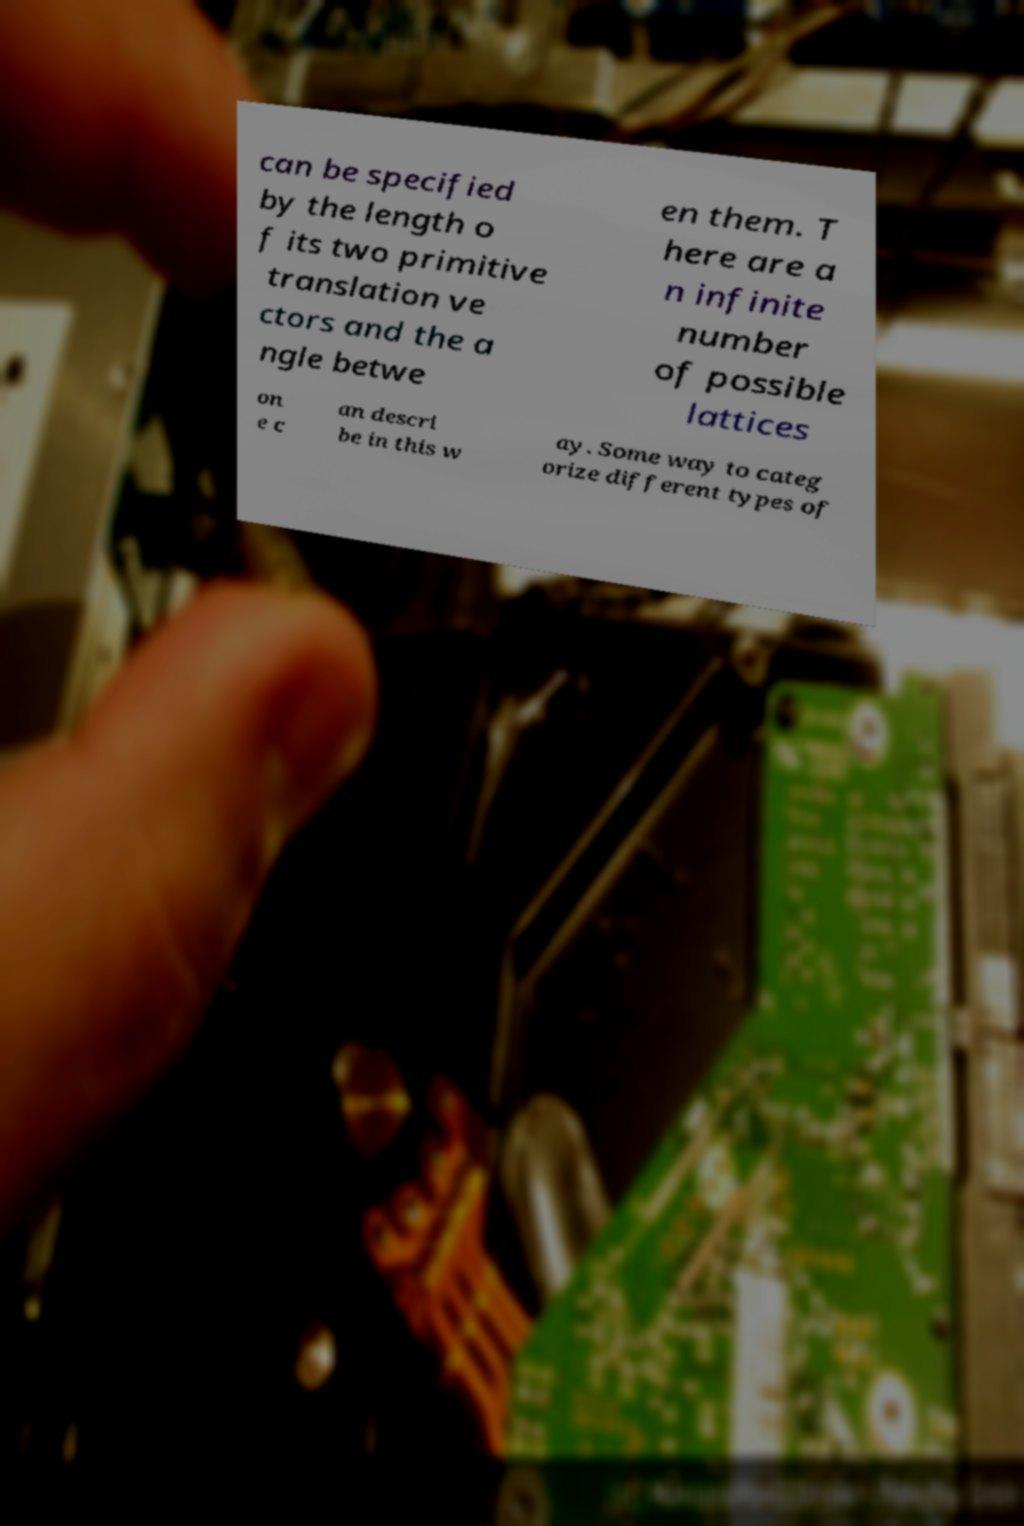What messages or text are displayed in this image? I need them in a readable, typed format. can be specified by the length o f its two primitive translation ve ctors and the a ngle betwe en them. T here are a n infinite number of possible lattices on e c an descri be in this w ay. Some way to categ orize different types of 